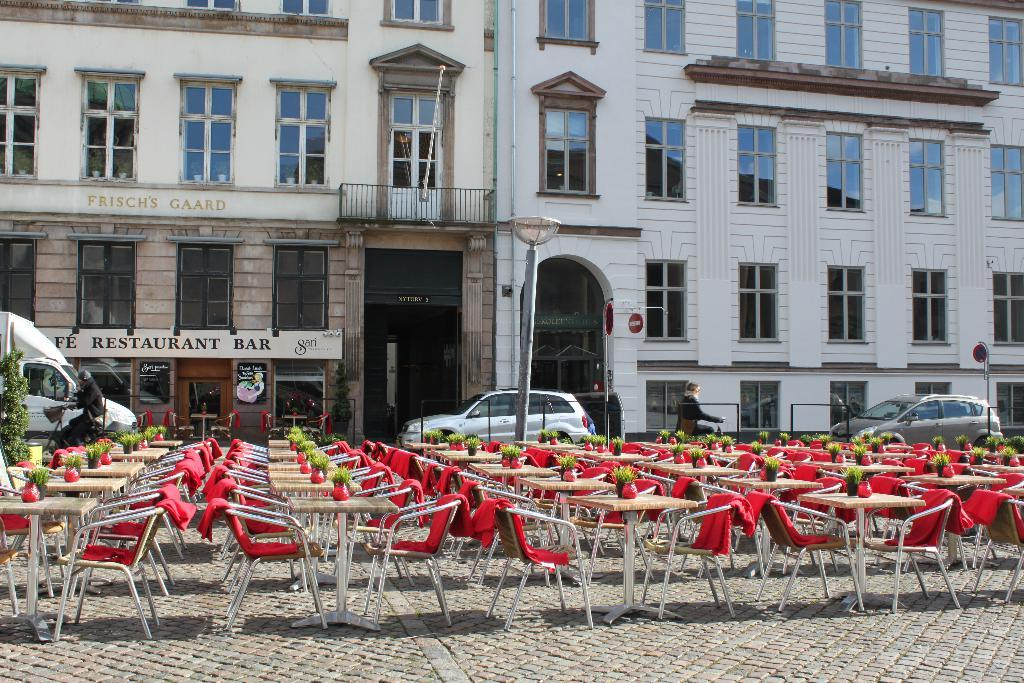What type of furniture is visible in the image? There are chairs and tables in the image. What are the plant pots placed on in the image? The plant pots are present on the tables in the image. What can be seen in the background of the image? There are vehicles, a pole, and buildings visible in the background. How many bricks can be seen in the image? There is no mention of bricks in the image, so it is impossible to determine their number. 